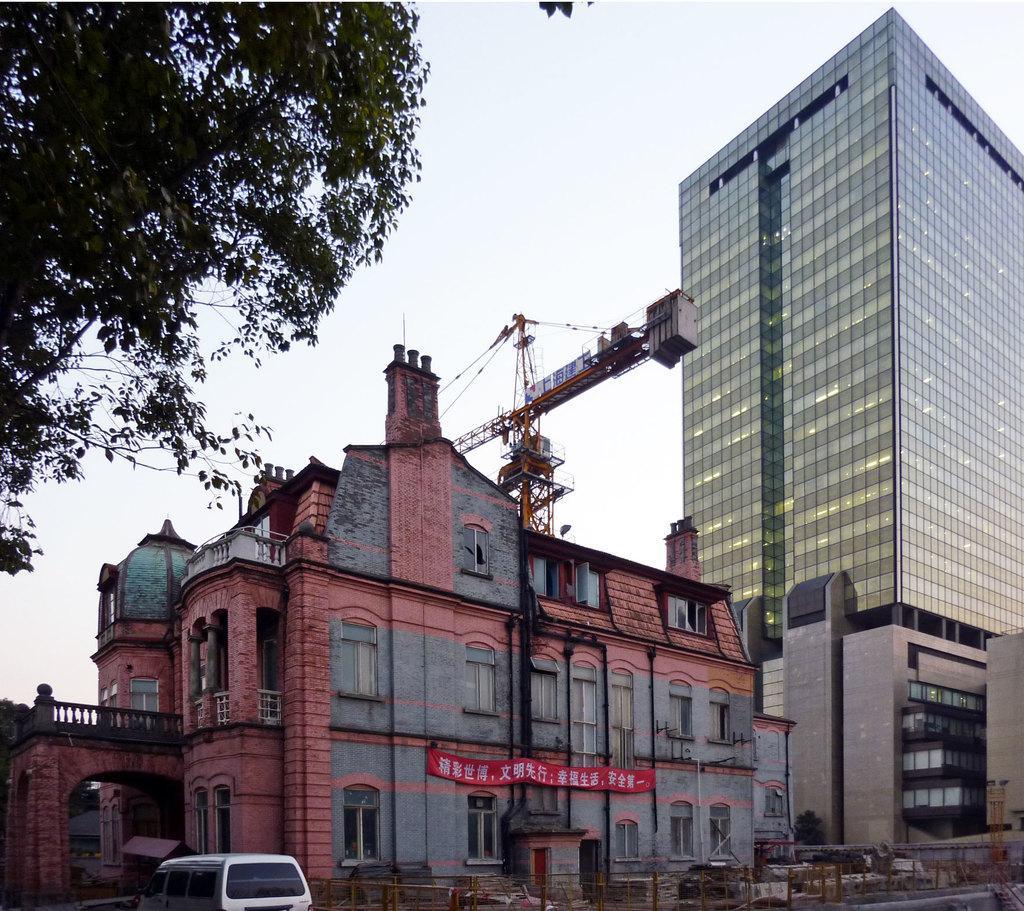Can you describe this image briefly? In the image we can see there are buildings, these are the windows of the building. We can even see a vehicle, white in color. Here we can see a building crane and a tree. There is a banner and a sky. 